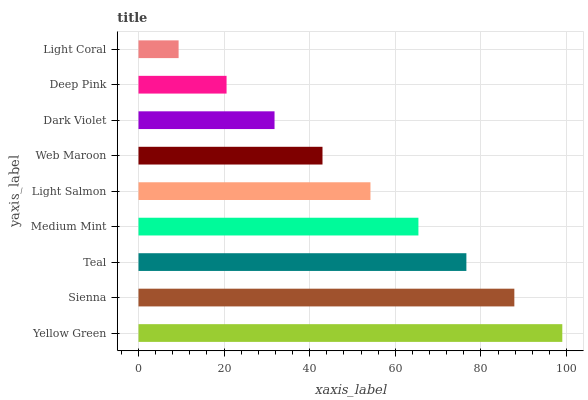Is Light Coral the minimum?
Answer yes or no. Yes. Is Yellow Green the maximum?
Answer yes or no. Yes. Is Sienna the minimum?
Answer yes or no. No. Is Sienna the maximum?
Answer yes or no. No. Is Yellow Green greater than Sienna?
Answer yes or no. Yes. Is Sienna less than Yellow Green?
Answer yes or no. Yes. Is Sienna greater than Yellow Green?
Answer yes or no. No. Is Yellow Green less than Sienna?
Answer yes or no. No. Is Light Salmon the high median?
Answer yes or no. Yes. Is Light Salmon the low median?
Answer yes or no. Yes. Is Deep Pink the high median?
Answer yes or no. No. Is Dark Violet the low median?
Answer yes or no. No. 